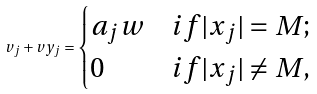Convert formula to latex. <formula><loc_0><loc_0><loc_500><loc_500>v _ { j } + v y _ { j } = \begin{cases} a _ { j } w & i f | x _ { j } | = M ; \\ 0 & i f | x _ { j } | \neq M , \end{cases}</formula> 